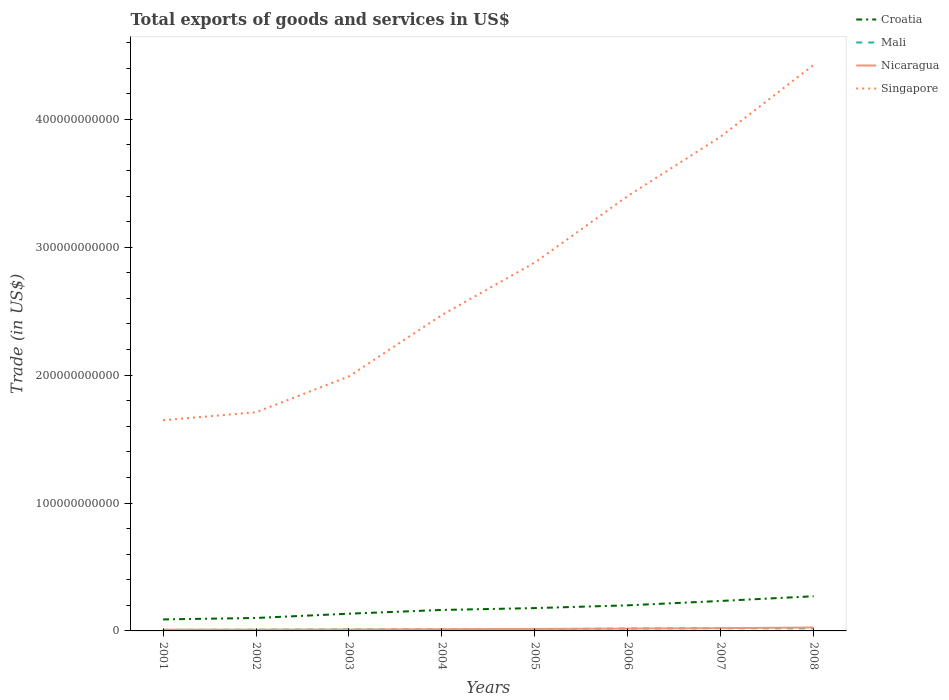Across all years, what is the maximum total exports of goods and services in Singapore?
Make the answer very short. 1.65e+11. In which year was the total exports of goods and services in Croatia maximum?
Offer a very short reply. 2001. What is the total total exports of goods and services in Mali in the graph?
Make the answer very short. -8.85e+08. What is the difference between the highest and the second highest total exports of goods and services in Nicaragua?
Offer a terse response. 1.68e+09. Is the total exports of goods and services in Singapore strictly greater than the total exports of goods and services in Nicaragua over the years?
Your answer should be very brief. No. How many years are there in the graph?
Offer a very short reply. 8. What is the difference between two consecutive major ticks on the Y-axis?
Ensure brevity in your answer.  1.00e+11. Does the graph contain any zero values?
Give a very brief answer. No. Where does the legend appear in the graph?
Provide a short and direct response. Top right. How are the legend labels stacked?
Ensure brevity in your answer.  Vertical. What is the title of the graph?
Your answer should be compact. Total exports of goods and services in US$. What is the label or title of the Y-axis?
Keep it short and to the point. Trade (in US$). What is the Trade (in US$) of Croatia in 2001?
Ensure brevity in your answer.  9.00e+09. What is the Trade (in US$) of Mali in 2001?
Your answer should be very brief. 7.89e+08. What is the Trade (in US$) of Nicaragua in 2001?
Offer a very short reply. 1.01e+09. What is the Trade (in US$) of Singapore in 2001?
Offer a terse response. 1.65e+11. What is the Trade (in US$) of Croatia in 2002?
Your response must be concise. 1.01e+1. What is the Trade (in US$) in Mali in 2002?
Make the answer very short. 9.47e+08. What is the Trade (in US$) in Nicaragua in 2002?
Your answer should be compact. 9.85e+08. What is the Trade (in US$) of Singapore in 2002?
Provide a succinct answer. 1.71e+11. What is the Trade (in US$) of Croatia in 2003?
Offer a terse response. 1.35e+1. What is the Trade (in US$) of Mali in 2003?
Provide a short and direct response. 1.15e+09. What is the Trade (in US$) in Nicaragua in 2003?
Keep it short and to the point. 1.10e+09. What is the Trade (in US$) of Singapore in 2003?
Offer a very short reply. 1.99e+11. What is the Trade (in US$) in Croatia in 2004?
Your answer should be compact. 1.64e+1. What is the Trade (in US$) of Mali in 2004?
Offer a very short reply. 1.22e+09. What is the Trade (in US$) in Nicaragua in 2004?
Your answer should be very brief. 1.34e+09. What is the Trade (in US$) in Singapore in 2004?
Your response must be concise. 2.47e+11. What is the Trade (in US$) in Croatia in 2005?
Your answer should be compact. 1.78e+1. What is the Trade (in US$) in Mali in 2005?
Keep it short and to the point. 1.37e+09. What is the Trade (in US$) of Nicaragua in 2005?
Provide a short and direct response. 1.54e+09. What is the Trade (in US$) in Singapore in 2005?
Offer a terse response. 2.88e+11. What is the Trade (in US$) in Croatia in 2006?
Provide a short and direct response. 2.00e+1. What is the Trade (in US$) in Mali in 2006?
Offer a terse response. 1.83e+09. What is the Trade (in US$) of Nicaragua in 2006?
Offer a very short reply. 1.83e+09. What is the Trade (in US$) of Singapore in 2006?
Provide a succinct answer. 3.40e+11. What is the Trade (in US$) of Croatia in 2007?
Offer a terse response. 2.34e+1. What is the Trade (in US$) in Mali in 2007?
Offer a terse response. 2.08e+09. What is the Trade (in US$) in Nicaragua in 2007?
Provide a short and direct response. 2.16e+09. What is the Trade (in US$) of Singapore in 2007?
Your response must be concise. 3.86e+11. What is the Trade (in US$) of Croatia in 2008?
Make the answer very short. 2.71e+1. What is the Trade (in US$) of Mali in 2008?
Give a very brief answer. 2.00e+09. What is the Trade (in US$) of Nicaragua in 2008?
Offer a terse response. 2.66e+09. What is the Trade (in US$) in Singapore in 2008?
Make the answer very short. 4.43e+11. Across all years, what is the maximum Trade (in US$) in Croatia?
Give a very brief answer. 2.71e+1. Across all years, what is the maximum Trade (in US$) in Mali?
Offer a terse response. 2.08e+09. Across all years, what is the maximum Trade (in US$) in Nicaragua?
Keep it short and to the point. 2.66e+09. Across all years, what is the maximum Trade (in US$) of Singapore?
Offer a very short reply. 4.43e+11. Across all years, what is the minimum Trade (in US$) of Croatia?
Your answer should be very brief. 9.00e+09. Across all years, what is the minimum Trade (in US$) of Mali?
Provide a short and direct response. 7.89e+08. Across all years, what is the minimum Trade (in US$) in Nicaragua?
Offer a very short reply. 9.85e+08. Across all years, what is the minimum Trade (in US$) of Singapore?
Make the answer very short. 1.65e+11. What is the total Trade (in US$) of Croatia in the graph?
Offer a very short reply. 1.37e+11. What is the total Trade (in US$) in Mali in the graph?
Provide a short and direct response. 1.14e+1. What is the total Trade (in US$) in Nicaragua in the graph?
Offer a very short reply. 1.26e+1. What is the total Trade (in US$) of Singapore in the graph?
Provide a succinct answer. 2.24e+12. What is the difference between the Trade (in US$) in Croatia in 2001 and that in 2002?
Provide a succinct answer. -1.12e+09. What is the difference between the Trade (in US$) in Mali in 2001 and that in 2002?
Your answer should be very brief. -1.58e+08. What is the difference between the Trade (in US$) of Nicaragua in 2001 and that in 2002?
Keep it short and to the point. 2.90e+07. What is the difference between the Trade (in US$) in Singapore in 2001 and that in 2002?
Offer a very short reply. -6.26e+09. What is the difference between the Trade (in US$) of Croatia in 2001 and that in 2003?
Offer a very short reply. -4.47e+09. What is the difference between the Trade (in US$) in Mali in 2001 and that in 2003?
Provide a short and direct response. -3.63e+08. What is the difference between the Trade (in US$) of Nicaragua in 2001 and that in 2003?
Provide a succinct answer. -8.84e+07. What is the difference between the Trade (in US$) of Singapore in 2001 and that in 2003?
Offer a very short reply. -3.43e+1. What is the difference between the Trade (in US$) of Croatia in 2001 and that in 2004?
Keep it short and to the point. -7.40e+09. What is the difference between the Trade (in US$) in Mali in 2001 and that in 2004?
Give a very brief answer. -4.28e+08. What is the difference between the Trade (in US$) of Nicaragua in 2001 and that in 2004?
Give a very brief answer. -3.23e+08. What is the difference between the Trade (in US$) of Singapore in 2001 and that in 2004?
Keep it short and to the point. -8.23e+1. What is the difference between the Trade (in US$) in Croatia in 2001 and that in 2005?
Offer a very short reply. -8.84e+09. What is the difference between the Trade (in US$) in Mali in 2001 and that in 2005?
Give a very brief answer. -5.84e+08. What is the difference between the Trade (in US$) of Nicaragua in 2001 and that in 2005?
Your answer should be very brief. -5.28e+08. What is the difference between the Trade (in US$) of Singapore in 2001 and that in 2005?
Make the answer very short. -1.23e+11. What is the difference between the Trade (in US$) in Croatia in 2001 and that in 2006?
Give a very brief answer. -1.10e+1. What is the difference between the Trade (in US$) in Mali in 2001 and that in 2006?
Offer a very short reply. -1.04e+09. What is the difference between the Trade (in US$) of Nicaragua in 2001 and that in 2006?
Your response must be concise. -8.21e+08. What is the difference between the Trade (in US$) of Singapore in 2001 and that in 2006?
Your response must be concise. -1.75e+11. What is the difference between the Trade (in US$) in Croatia in 2001 and that in 2007?
Give a very brief answer. -1.44e+1. What is the difference between the Trade (in US$) in Mali in 2001 and that in 2007?
Make the answer very short. -1.29e+09. What is the difference between the Trade (in US$) in Nicaragua in 2001 and that in 2007?
Ensure brevity in your answer.  -1.15e+09. What is the difference between the Trade (in US$) of Singapore in 2001 and that in 2007?
Make the answer very short. -2.22e+11. What is the difference between the Trade (in US$) of Croatia in 2001 and that in 2008?
Your answer should be compact. -1.81e+1. What is the difference between the Trade (in US$) in Mali in 2001 and that in 2008?
Give a very brief answer. -1.21e+09. What is the difference between the Trade (in US$) in Nicaragua in 2001 and that in 2008?
Make the answer very short. -1.65e+09. What is the difference between the Trade (in US$) in Singapore in 2001 and that in 2008?
Your answer should be compact. -2.78e+11. What is the difference between the Trade (in US$) of Croatia in 2002 and that in 2003?
Make the answer very short. -3.35e+09. What is the difference between the Trade (in US$) in Mali in 2002 and that in 2003?
Keep it short and to the point. -2.05e+08. What is the difference between the Trade (in US$) in Nicaragua in 2002 and that in 2003?
Provide a short and direct response. -1.17e+08. What is the difference between the Trade (in US$) in Singapore in 2002 and that in 2003?
Ensure brevity in your answer.  -2.80e+1. What is the difference between the Trade (in US$) of Croatia in 2002 and that in 2004?
Your response must be concise. -6.28e+09. What is the difference between the Trade (in US$) of Mali in 2002 and that in 2004?
Keep it short and to the point. -2.70e+08. What is the difference between the Trade (in US$) in Nicaragua in 2002 and that in 2004?
Offer a very short reply. -3.52e+08. What is the difference between the Trade (in US$) of Singapore in 2002 and that in 2004?
Your answer should be compact. -7.61e+1. What is the difference between the Trade (in US$) in Croatia in 2002 and that in 2005?
Offer a terse response. -7.72e+09. What is the difference between the Trade (in US$) in Mali in 2002 and that in 2005?
Ensure brevity in your answer.  -4.26e+08. What is the difference between the Trade (in US$) in Nicaragua in 2002 and that in 2005?
Your response must be concise. -5.57e+08. What is the difference between the Trade (in US$) in Singapore in 2002 and that in 2005?
Keep it short and to the point. -1.17e+11. What is the difference between the Trade (in US$) of Croatia in 2002 and that in 2006?
Give a very brief answer. -9.89e+09. What is the difference between the Trade (in US$) in Mali in 2002 and that in 2006?
Your answer should be very brief. -8.85e+08. What is the difference between the Trade (in US$) in Nicaragua in 2002 and that in 2006?
Provide a short and direct response. -8.50e+08. What is the difference between the Trade (in US$) in Singapore in 2002 and that in 2006?
Ensure brevity in your answer.  -1.69e+11. What is the difference between the Trade (in US$) in Croatia in 2002 and that in 2007?
Give a very brief answer. -1.33e+1. What is the difference between the Trade (in US$) in Mali in 2002 and that in 2007?
Your answer should be compact. -1.13e+09. What is the difference between the Trade (in US$) in Nicaragua in 2002 and that in 2007?
Ensure brevity in your answer.  -1.18e+09. What is the difference between the Trade (in US$) in Singapore in 2002 and that in 2007?
Your answer should be compact. -2.16e+11. What is the difference between the Trade (in US$) of Croatia in 2002 and that in 2008?
Provide a short and direct response. -1.70e+1. What is the difference between the Trade (in US$) of Mali in 2002 and that in 2008?
Offer a terse response. -1.05e+09. What is the difference between the Trade (in US$) of Nicaragua in 2002 and that in 2008?
Provide a succinct answer. -1.68e+09. What is the difference between the Trade (in US$) in Singapore in 2002 and that in 2008?
Your answer should be very brief. -2.72e+11. What is the difference between the Trade (in US$) of Croatia in 2003 and that in 2004?
Your response must be concise. -2.92e+09. What is the difference between the Trade (in US$) in Mali in 2003 and that in 2004?
Ensure brevity in your answer.  -6.55e+07. What is the difference between the Trade (in US$) of Nicaragua in 2003 and that in 2004?
Offer a very short reply. -2.34e+08. What is the difference between the Trade (in US$) of Singapore in 2003 and that in 2004?
Your answer should be very brief. -4.80e+1. What is the difference between the Trade (in US$) in Croatia in 2003 and that in 2005?
Make the answer very short. -4.37e+09. What is the difference between the Trade (in US$) of Mali in 2003 and that in 2005?
Your response must be concise. -2.21e+08. What is the difference between the Trade (in US$) in Nicaragua in 2003 and that in 2005?
Your response must be concise. -4.39e+08. What is the difference between the Trade (in US$) in Singapore in 2003 and that in 2005?
Offer a terse response. -8.91e+1. What is the difference between the Trade (in US$) of Croatia in 2003 and that in 2006?
Offer a very short reply. -6.53e+09. What is the difference between the Trade (in US$) of Mali in 2003 and that in 2006?
Provide a succinct answer. -6.80e+08. What is the difference between the Trade (in US$) in Nicaragua in 2003 and that in 2006?
Provide a short and direct response. -7.33e+08. What is the difference between the Trade (in US$) in Singapore in 2003 and that in 2006?
Make the answer very short. -1.41e+11. What is the difference between the Trade (in US$) of Croatia in 2003 and that in 2007?
Ensure brevity in your answer.  -9.96e+09. What is the difference between the Trade (in US$) of Mali in 2003 and that in 2007?
Keep it short and to the point. -9.26e+08. What is the difference between the Trade (in US$) of Nicaragua in 2003 and that in 2007?
Keep it short and to the point. -1.06e+09. What is the difference between the Trade (in US$) of Singapore in 2003 and that in 2007?
Offer a terse response. -1.87e+11. What is the difference between the Trade (in US$) in Croatia in 2003 and that in 2008?
Offer a terse response. -1.36e+1. What is the difference between the Trade (in US$) in Mali in 2003 and that in 2008?
Provide a succinct answer. -8.49e+08. What is the difference between the Trade (in US$) of Nicaragua in 2003 and that in 2008?
Offer a terse response. -1.56e+09. What is the difference between the Trade (in US$) of Singapore in 2003 and that in 2008?
Ensure brevity in your answer.  -2.44e+11. What is the difference between the Trade (in US$) of Croatia in 2004 and that in 2005?
Provide a succinct answer. -1.44e+09. What is the difference between the Trade (in US$) of Mali in 2004 and that in 2005?
Provide a short and direct response. -1.56e+08. What is the difference between the Trade (in US$) in Nicaragua in 2004 and that in 2005?
Offer a very short reply. -2.05e+08. What is the difference between the Trade (in US$) of Singapore in 2004 and that in 2005?
Make the answer very short. -4.10e+1. What is the difference between the Trade (in US$) in Croatia in 2004 and that in 2006?
Provide a succinct answer. -3.61e+09. What is the difference between the Trade (in US$) of Mali in 2004 and that in 2006?
Your response must be concise. -6.14e+08. What is the difference between the Trade (in US$) in Nicaragua in 2004 and that in 2006?
Make the answer very short. -4.98e+08. What is the difference between the Trade (in US$) in Singapore in 2004 and that in 2006?
Give a very brief answer. -9.31e+1. What is the difference between the Trade (in US$) of Croatia in 2004 and that in 2007?
Offer a terse response. -7.03e+09. What is the difference between the Trade (in US$) of Mali in 2004 and that in 2007?
Your answer should be compact. -8.60e+08. What is the difference between the Trade (in US$) of Nicaragua in 2004 and that in 2007?
Provide a short and direct response. -8.28e+08. What is the difference between the Trade (in US$) in Singapore in 2004 and that in 2007?
Ensure brevity in your answer.  -1.39e+11. What is the difference between the Trade (in US$) of Croatia in 2004 and that in 2008?
Your answer should be compact. -1.07e+1. What is the difference between the Trade (in US$) in Mali in 2004 and that in 2008?
Offer a terse response. -7.84e+08. What is the difference between the Trade (in US$) in Nicaragua in 2004 and that in 2008?
Provide a succinct answer. -1.32e+09. What is the difference between the Trade (in US$) in Singapore in 2004 and that in 2008?
Provide a succinct answer. -1.96e+11. What is the difference between the Trade (in US$) of Croatia in 2005 and that in 2006?
Give a very brief answer. -2.17e+09. What is the difference between the Trade (in US$) of Mali in 2005 and that in 2006?
Keep it short and to the point. -4.59e+08. What is the difference between the Trade (in US$) in Nicaragua in 2005 and that in 2006?
Your answer should be very brief. -2.94e+08. What is the difference between the Trade (in US$) of Singapore in 2005 and that in 2006?
Give a very brief answer. -5.20e+1. What is the difference between the Trade (in US$) of Croatia in 2005 and that in 2007?
Provide a short and direct response. -5.59e+09. What is the difference between the Trade (in US$) of Mali in 2005 and that in 2007?
Offer a terse response. -7.05e+08. What is the difference between the Trade (in US$) in Nicaragua in 2005 and that in 2007?
Ensure brevity in your answer.  -6.23e+08. What is the difference between the Trade (in US$) of Singapore in 2005 and that in 2007?
Your answer should be compact. -9.84e+1. What is the difference between the Trade (in US$) in Croatia in 2005 and that in 2008?
Offer a very short reply. -9.27e+09. What is the difference between the Trade (in US$) of Mali in 2005 and that in 2008?
Your answer should be very brief. -6.28e+08. What is the difference between the Trade (in US$) of Nicaragua in 2005 and that in 2008?
Your answer should be compact. -1.12e+09. What is the difference between the Trade (in US$) of Singapore in 2005 and that in 2008?
Ensure brevity in your answer.  -1.55e+11. What is the difference between the Trade (in US$) of Croatia in 2006 and that in 2007?
Provide a succinct answer. -3.43e+09. What is the difference between the Trade (in US$) of Mali in 2006 and that in 2007?
Your answer should be very brief. -2.46e+08. What is the difference between the Trade (in US$) in Nicaragua in 2006 and that in 2007?
Your answer should be compact. -3.29e+08. What is the difference between the Trade (in US$) of Singapore in 2006 and that in 2007?
Give a very brief answer. -4.64e+1. What is the difference between the Trade (in US$) in Croatia in 2006 and that in 2008?
Your response must be concise. -7.11e+09. What is the difference between the Trade (in US$) of Mali in 2006 and that in 2008?
Offer a very short reply. -1.69e+08. What is the difference between the Trade (in US$) of Nicaragua in 2006 and that in 2008?
Give a very brief answer. -8.25e+08. What is the difference between the Trade (in US$) in Singapore in 2006 and that in 2008?
Give a very brief answer. -1.03e+11. What is the difference between the Trade (in US$) in Croatia in 2007 and that in 2008?
Your response must be concise. -3.68e+09. What is the difference between the Trade (in US$) of Mali in 2007 and that in 2008?
Ensure brevity in your answer.  7.64e+07. What is the difference between the Trade (in US$) in Nicaragua in 2007 and that in 2008?
Keep it short and to the point. -4.96e+08. What is the difference between the Trade (in US$) of Singapore in 2007 and that in 2008?
Offer a very short reply. -5.61e+1. What is the difference between the Trade (in US$) of Croatia in 2001 and the Trade (in US$) of Mali in 2002?
Give a very brief answer. 8.06e+09. What is the difference between the Trade (in US$) of Croatia in 2001 and the Trade (in US$) of Nicaragua in 2002?
Keep it short and to the point. 8.02e+09. What is the difference between the Trade (in US$) in Croatia in 2001 and the Trade (in US$) in Singapore in 2002?
Provide a succinct answer. -1.62e+11. What is the difference between the Trade (in US$) of Mali in 2001 and the Trade (in US$) of Nicaragua in 2002?
Provide a short and direct response. -1.95e+08. What is the difference between the Trade (in US$) in Mali in 2001 and the Trade (in US$) in Singapore in 2002?
Keep it short and to the point. -1.70e+11. What is the difference between the Trade (in US$) in Nicaragua in 2001 and the Trade (in US$) in Singapore in 2002?
Make the answer very short. -1.70e+11. What is the difference between the Trade (in US$) of Croatia in 2001 and the Trade (in US$) of Mali in 2003?
Make the answer very short. 7.85e+09. What is the difference between the Trade (in US$) of Croatia in 2001 and the Trade (in US$) of Nicaragua in 2003?
Your answer should be compact. 7.90e+09. What is the difference between the Trade (in US$) of Croatia in 2001 and the Trade (in US$) of Singapore in 2003?
Your response must be concise. -1.90e+11. What is the difference between the Trade (in US$) of Mali in 2001 and the Trade (in US$) of Nicaragua in 2003?
Your answer should be compact. -3.13e+08. What is the difference between the Trade (in US$) in Mali in 2001 and the Trade (in US$) in Singapore in 2003?
Make the answer very short. -1.98e+11. What is the difference between the Trade (in US$) in Nicaragua in 2001 and the Trade (in US$) in Singapore in 2003?
Make the answer very short. -1.98e+11. What is the difference between the Trade (in US$) of Croatia in 2001 and the Trade (in US$) of Mali in 2004?
Keep it short and to the point. 7.79e+09. What is the difference between the Trade (in US$) of Croatia in 2001 and the Trade (in US$) of Nicaragua in 2004?
Give a very brief answer. 7.67e+09. What is the difference between the Trade (in US$) in Croatia in 2001 and the Trade (in US$) in Singapore in 2004?
Provide a short and direct response. -2.38e+11. What is the difference between the Trade (in US$) of Mali in 2001 and the Trade (in US$) of Nicaragua in 2004?
Ensure brevity in your answer.  -5.47e+08. What is the difference between the Trade (in US$) in Mali in 2001 and the Trade (in US$) in Singapore in 2004?
Ensure brevity in your answer.  -2.46e+11. What is the difference between the Trade (in US$) in Nicaragua in 2001 and the Trade (in US$) in Singapore in 2004?
Make the answer very short. -2.46e+11. What is the difference between the Trade (in US$) in Croatia in 2001 and the Trade (in US$) in Mali in 2005?
Offer a very short reply. 7.63e+09. What is the difference between the Trade (in US$) of Croatia in 2001 and the Trade (in US$) of Nicaragua in 2005?
Your answer should be very brief. 7.46e+09. What is the difference between the Trade (in US$) of Croatia in 2001 and the Trade (in US$) of Singapore in 2005?
Make the answer very short. -2.79e+11. What is the difference between the Trade (in US$) of Mali in 2001 and the Trade (in US$) of Nicaragua in 2005?
Make the answer very short. -7.52e+08. What is the difference between the Trade (in US$) in Mali in 2001 and the Trade (in US$) in Singapore in 2005?
Ensure brevity in your answer.  -2.87e+11. What is the difference between the Trade (in US$) of Nicaragua in 2001 and the Trade (in US$) of Singapore in 2005?
Your answer should be compact. -2.87e+11. What is the difference between the Trade (in US$) in Croatia in 2001 and the Trade (in US$) in Mali in 2006?
Make the answer very short. 7.17e+09. What is the difference between the Trade (in US$) in Croatia in 2001 and the Trade (in US$) in Nicaragua in 2006?
Your answer should be very brief. 7.17e+09. What is the difference between the Trade (in US$) of Croatia in 2001 and the Trade (in US$) of Singapore in 2006?
Offer a very short reply. -3.31e+11. What is the difference between the Trade (in US$) of Mali in 2001 and the Trade (in US$) of Nicaragua in 2006?
Provide a succinct answer. -1.05e+09. What is the difference between the Trade (in US$) of Mali in 2001 and the Trade (in US$) of Singapore in 2006?
Give a very brief answer. -3.39e+11. What is the difference between the Trade (in US$) in Nicaragua in 2001 and the Trade (in US$) in Singapore in 2006?
Provide a succinct answer. -3.39e+11. What is the difference between the Trade (in US$) of Croatia in 2001 and the Trade (in US$) of Mali in 2007?
Provide a succinct answer. 6.93e+09. What is the difference between the Trade (in US$) in Croatia in 2001 and the Trade (in US$) in Nicaragua in 2007?
Offer a terse response. 6.84e+09. What is the difference between the Trade (in US$) of Croatia in 2001 and the Trade (in US$) of Singapore in 2007?
Provide a short and direct response. -3.77e+11. What is the difference between the Trade (in US$) in Mali in 2001 and the Trade (in US$) in Nicaragua in 2007?
Provide a short and direct response. -1.38e+09. What is the difference between the Trade (in US$) of Mali in 2001 and the Trade (in US$) of Singapore in 2007?
Offer a terse response. -3.86e+11. What is the difference between the Trade (in US$) of Nicaragua in 2001 and the Trade (in US$) of Singapore in 2007?
Your answer should be very brief. -3.85e+11. What is the difference between the Trade (in US$) in Croatia in 2001 and the Trade (in US$) in Mali in 2008?
Provide a succinct answer. 7.00e+09. What is the difference between the Trade (in US$) in Croatia in 2001 and the Trade (in US$) in Nicaragua in 2008?
Make the answer very short. 6.34e+09. What is the difference between the Trade (in US$) in Croatia in 2001 and the Trade (in US$) in Singapore in 2008?
Ensure brevity in your answer.  -4.34e+11. What is the difference between the Trade (in US$) in Mali in 2001 and the Trade (in US$) in Nicaragua in 2008?
Offer a terse response. -1.87e+09. What is the difference between the Trade (in US$) of Mali in 2001 and the Trade (in US$) of Singapore in 2008?
Ensure brevity in your answer.  -4.42e+11. What is the difference between the Trade (in US$) in Nicaragua in 2001 and the Trade (in US$) in Singapore in 2008?
Keep it short and to the point. -4.42e+11. What is the difference between the Trade (in US$) in Croatia in 2002 and the Trade (in US$) in Mali in 2003?
Offer a terse response. 8.97e+09. What is the difference between the Trade (in US$) in Croatia in 2002 and the Trade (in US$) in Nicaragua in 2003?
Give a very brief answer. 9.02e+09. What is the difference between the Trade (in US$) of Croatia in 2002 and the Trade (in US$) of Singapore in 2003?
Provide a short and direct response. -1.89e+11. What is the difference between the Trade (in US$) of Mali in 2002 and the Trade (in US$) of Nicaragua in 2003?
Provide a short and direct response. -1.55e+08. What is the difference between the Trade (in US$) in Mali in 2002 and the Trade (in US$) in Singapore in 2003?
Give a very brief answer. -1.98e+11. What is the difference between the Trade (in US$) in Nicaragua in 2002 and the Trade (in US$) in Singapore in 2003?
Keep it short and to the point. -1.98e+11. What is the difference between the Trade (in US$) in Croatia in 2002 and the Trade (in US$) in Mali in 2004?
Offer a very short reply. 8.91e+09. What is the difference between the Trade (in US$) in Croatia in 2002 and the Trade (in US$) in Nicaragua in 2004?
Give a very brief answer. 8.79e+09. What is the difference between the Trade (in US$) in Croatia in 2002 and the Trade (in US$) in Singapore in 2004?
Give a very brief answer. -2.37e+11. What is the difference between the Trade (in US$) of Mali in 2002 and the Trade (in US$) of Nicaragua in 2004?
Give a very brief answer. -3.89e+08. What is the difference between the Trade (in US$) in Mali in 2002 and the Trade (in US$) in Singapore in 2004?
Your answer should be very brief. -2.46e+11. What is the difference between the Trade (in US$) of Nicaragua in 2002 and the Trade (in US$) of Singapore in 2004?
Offer a terse response. -2.46e+11. What is the difference between the Trade (in US$) of Croatia in 2002 and the Trade (in US$) of Mali in 2005?
Keep it short and to the point. 8.75e+09. What is the difference between the Trade (in US$) in Croatia in 2002 and the Trade (in US$) in Nicaragua in 2005?
Keep it short and to the point. 8.58e+09. What is the difference between the Trade (in US$) of Croatia in 2002 and the Trade (in US$) of Singapore in 2005?
Offer a very short reply. -2.78e+11. What is the difference between the Trade (in US$) in Mali in 2002 and the Trade (in US$) in Nicaragua in 2005?
Keep it short and to the point. -5.94e+08. What is the difference between the Trade (in US$) in Mali in 2002 and the Trade (in US$) in Singapore in 2005?
Your answer should be compact. -2.87e+11. What is the difference between the Trade (in US$) in Nicaragua in 2002 and the Trade (in US$) in Singapore in 2005?
Offer a very short reply. -2.87e+11. What is the difference between the Trade (in US$) of Croatia in 2002 and the Trade (in US$) of Mali in 2006?
Give a very brief answer. 8.29e+09. What is the difference between the Trade (in US$) in Croatia in 2002 and the Trade (in US$) in Nicaragua in 2006?
Give a very brief answer. 8.29e+09. What is the difference between the Trade (in US$) of Croatia in 2002 and the Trade (in US$) of Singapore in 2006?
Keep it short and to the point. -3.30e+11. What is the difference between the Trade (in US$) in Mali in 2002 and the Trade (in US$) in Nicaragua in 2006?
Your answer should be very brief. -8.88e+08. What is the difference between the Trade (in US$) in Mali in 2002 and the Trade (in US$) in Singapore in 2006?
Make the answer very short. -3.39e+11. What is the difference between the Trade (in US$) of Nicaragua in 2002 and the Trade (in US$) of Singapore in 2006?
Provide a succinct answer. -3.39e+11. What is the difference between the Trade (in US$) in Croatia in 2002 and the Trade (in US$) in Mali in 2007?
Give a very brief answer. 8.05e+09. What is the difference between the Trade (in US$) of Croatia in 2002 and the Trade (in US$) of Nicaragua in 2007?
Give a very brief answer. 7.96e+09. What is the difference between the Trade (in US$) of Croatia in 2002 and the Trade (in US$) of Singapore in 2007?
Ensure brevity in your answer.  -3.76e+11. What is the difference between the Trade (in US$) in Mali in 2002 and the Trade (in US$) in Nicaragua in 2007?
Your response must be concise. -1.22e+09. What is the difference between the Trade (in US$) in Mali in 2002 and the Trade (in US$) in Singapore in 2007?
Keep it short and to the point. -3.86e+11. What is the difference between the Trade (in US$) of Nicaragua in 2002 and the Trade (in US$) of Singapore in 2007?
Offer a terse response. -3.86e+11. What is the difference between the Trade (in US$) of Croatia in 2002 and the Trade (in US$) of Mali in 2008?
Keep it short and to the point. 8.12e+09. What is the difference between the Trade (in US$) in Croatia in 2002 and the Trade (in US$) in Nicaragua in 2008?
Your response must be concise. 7.47e+09. What is the difference between the Trade (in US$) in Croatia in 2002 and the Trade (in US$) in Singapore in 2008?
Make the answer very short. -4.33e+11. What is the difference between the Trade (in US$) in Mali in 2002 and the Trade (in US$) in Nicaragua in 2008?
Ensure brevity in your answer.  -1.71e+09. What is the difference between the Trade (in US$) in Mali in 2002 and the Trade (in US$) in Singapore in 2008?
Offer a terse response. -4.42e+11. What is the difference between the Trade (in US$) in Nicaragua in 2002 and the Trade (in US$) in Singapore in 2008?
Provide a succinct answer. -4.42e+11. What is the difference between the Trade (in US$) in Croatia in 2003 and the Trade (in US$) in Mali in 2004?
Offer a very short reply. 1.23e+1. What is the difference between the Trade (in US$) in Croatia in 2003 and the Trade (in US$) in Nicaragua in 2004?
Give a very brief answer. 1.21e+1. What is the difference between the Trade (in US$) in Croatia in 2003 and the Trade (in US$) in Singapore in 2004?
Keep it short and to the point. -2.34e+11. What is the difference between the Trade (in US$) of Mali in 2003 and the Trade (in US$) of Nicaragua in 2004?
Keep it short and to the point. -1.84e+08. What is the difference between the Trade (in US$) in Mali in 2003 and the Trade (in US$) in Singapore in 2004?
Ensure brevity in your answer.  -2.46e+11. What is the difference between the Trade (in US$) in Nicaragua in 2003 and the Trade (in US$) in Singapore in 2004?
Ensure brevity in your answer.  -2.46e+11. What is the difference between the Trade (in US$) of Croatia in 2003 and the Trade (in US$) of Mali in 2005?
Your response must be concise. 1.21e+1. What is the difference between the Trade (in US$) in Croatia in 2003 and the Trade (in US$) in Nicaragua in 2005?
Offer a terse response. 1.19e+1. What is the difference between the Trade (in US$) in Croatia in 2003 and the Trade (in US$) in Singapore in 2005?
Your answer should be compact. -2.75e+11. What is the difference between the Trade (in US$) in Mali in 2003 and the Trade (in US$) in Nicaragua in 2005?
Give a very brief answer. -3.89e+08. What is the difference between the Trade (in US$) in Mali in 2003 and the Trade (in US$) in Singapore in 2005?
Offer a very short reply. -2.87e+11. What is the difference between the Trade (in US$) in Nicaragua in 2003 and the Trade (in US$) in Singapore in 2005?
Make the answer very short. -2.87e+11. What is the difference between the Trade (in US$) of Croatia in 2003 and the Trade (in US$) of Mali in 2006?
Your answer should be very brief. 1.16e+1. What is the difference between the Trade (in US$) in Croatia in 2003 and the Trade (in US$) in Nicaragua in 2006?
Offer a terse response. 1.16e+1. What is the difference between the Trade (in US$) in Croatia in 2003 and the Trade (in US$) in Singapore in 2006?
Make the answer very short. -3.27e+11. What is the difference between the Trade (in US$) of Mali in 2003 and the Trade (in US$) of Nicaragua in 2006?
Your answer should be compact. -6.83e+08. What is the difference between the Trade (in US$) in Mali in 2003 and the Trade (in US$) in Singapore in 2006?
Offer a terse response. -3.39e+11. What is the difference between the Trade (in US$) in Nicaragua in 2003 and the Trade (in US$) in Singapore in 2006?
Provide a succinct answer. -3.39e+11. What is the difference between the Trade (in US$) of Croatia in 2003 and the Trade (in US$) of Mali in 2007?
Make the answer very short. 1.14e+1. What is the difference between the Trade (in US$) in Croatia in 2003 and the Trade (in US$) in Nicaragua in 2007?
Offer a terse response. 1.13e+1. What is the difference between the Trade (in US$) of Croatia in 2003 and the Trade (in US$) of Singapore in 2007?
Your answer should be compact. -3.73e+11. What is the difference between the Trade (in US$) in Mali in 2003 and the Trade (in US$) in Nicaragua in 2007?
Give a very brief answer. -1.01e+09. What is the difference between the Trade (in US$) of Mali in 2003 and the Trade (in US$) of Singapore in 2007?
Provide a succinct answer. -3.85e+11. What is the difference between the Trade (in US$) of Nicaragua in 2003 and the Trade (in US$) of Singapore in 2007?
Provide a short and direct response. -3.85e+11. What is the difference between the Trade (in US$) of Croatia in 2003 and the Trade (in US$) of Mali in 2008?
Provide a short and direct response. 1.15e+1. What is the difference between the Trade (in US$) in Croatia in 2003 and the Trade (in US$) in Nicaragua in 2008?
Ensure brevity in your answer.  1.08e+1. What is the difference between the Trade (in US$) of Croatia in 2003 and the Trade (in US$) of Singapore in 2008?
Make the answer very short. -4.29e+11. What is the difference between the Trade (in US$) of Mali in 2003 and the Trade (in US$) of Nicaragua in 2008?
Your response must be concise. -1.51e+09. What is the difference between the Trade (in US$) of Mali in 2003 and the Trade (in US$) of Singapore in 2008?
Make the answer very short. -4.41e+11. What is the difference between the Trade (in US$) of Nicaragua in 2003 and the Trade (in US$) of Singapore in 2008?
Your answer should be compact. -4.42e+11. What is the difference between the Trade (in US$) of Croatia in 2004 and the Trade (in US$) of Mali in 2005?
Give a very brief answer. 1.50e+1. What is the difference between the Trade (in US$) of Croatia in 2004 and the Trade (in US$) of Nicaragua in 2005?
Make the answer very short. 1.49e+1. What is the difference between the Trade (in US$) in Croatia in 2004 and the Trade (in US$) in Singapore in 2005?
Provide a short and direct response. -2.72e+11. What is the difference between the Trade (in US$) in Mali in 2004 and the Trade (in US$) in Nicaragua in 2005?
Keep it short and to the point. -3.24e+08. What is the difference between the Trade (in US$) of Mali in 2004 and the Trade (in US$) of Singapore in 2005?
Your answer should be compact. -2.87e+11. What is the difference between the Trade (in US$) in Nicaragua in 2004 and the Trade (in US$) in Singapore in 2005?
Provide a succinct answer. -2.87e+11. What is the difference between the Trade (in US$) of Croatia in 2004 and the Trade (in US$) of Mali in 2006?
Offer a very short reply. 1.46e+1. What is the difference between the Trade (in US$) of Croatia in 2004 and the Trade (in US$) of Nicaragua in 2006?
Give a very brief answer. 1.46e+1. What is the difference between the Trade (in US$) of Croatia in 2004 and the Trade (in US$) of Singapore in 2006?
Your answer should be compact. -3.24e+11. What is the difference between the Trade (in US$) in Mali in 2004 and the Trade (in US$) in Nicaragua in 2006?
Offer a terse response. -6.17e+08. What is the difference between the Trade (in US$) in Mali in 2004 and the Trade (in US$) in Singapore in 2006?
Keep it short and to the point. -3.39e+11. What is the difference between the Trade (in US$) of Nicaragua in 2004 and the Trade (in US$) of Singapore in 2006?
Offer a terse response. -3.39e+11. What is the difference between the Trade (in US$) in Croatia in 2004 and the Trade (in US$) in Mali in 2007?
Keep it short and to the point. 1.43e+1. What is the difference between the Trade (in US$) of Croatia in 2004 and the Trade (in US$) of Nicaragua in 2007?
Your response must be concise. 1.42e+1. What is the difference between the Trade (in US$) in Croatia in 2004 and the Trade (in US$) in Singapore in 2007?
Your response must be concise. -3.70e+11. What is the difference between the Trade (in US$) of Mali in 2004 and the Trade (in US$) of Nicaragua in 2007?
Give a very brief answer. -9.47e+08. What is the difference between the Trade (in US$) in Mali in 2004 and the Trade (in US$) in Singapore in 2007?
Your response must be concise. -3.85e+11. What is the difference between the Trade (in US$) in Nicaragua in 2004 and the Trade (in US$) in Singapore in 2007?
Your answer should be compact. -3.85e+11. What is the difference between the Trade (in US$) in Croatia in 2004 and the Trade (in US$) in Mali in 2008?
Your answer should be compact. 1.44e+1. What is the difference between the Trade (in US$) in Croatia in 2004 and the Trade (in US$) in Nicaragua in 2008?
Provide a short and direct response. 1.37e+1. What is the difference between the Trade (in US$) in Croatia in 2004 and the Trade (in US$) in Singapore in 2008?
Your answer should be compact. -4.26e+11. What is the difference between the Trade (in US$) of Mali in 2004 and the Trade (in US$) of Nicaragua in 2008?
Your response must be concise. -1.44e+09. What is the difference between the Trade (in US$) of Mali in 2004 and the Trade (in US$) of Singapore in 2008?
Your response must be concise. -4.41e+11. What is the difference between the Trade (in US$) in Nicaragua in 2004 and the Trade (in US$) in Singapore in 2008?
Provide a short and direct response. -4.41e+11. What is the difference between the Trade (in US$) of Croatia in 2005 and the Trade (in US$) of Mali in 2006?
Offer a very short reply. 1.60e+1. What is the difference between the Trade (in US$) of Croatia in 2005 and the Trade (in US$) of Nicaragua in 2006?
Offer a terse response. 1.60e+1. What is the difference between the Trade (in US$) in Croatia in 2005 and the Trade (in US$) in Singapore in 2006?
Keep it short and to the point. -3.22e+11. What is the difference between the Trade (in US$) of Mali in 2005 and the Trade (in US$) of Nicaragua in 2006?
Ensure brevity in your answer.  -4.62e+08. What is the difference between the Trade (in US$) of Mali in 2005 and the Trade (in US$) of Singapore in 2006?
Keep it short and to the point. -3.39e+11. What is the difference between the Trade (in US$) in Nicaragua in 2005 and the Trade (in US$) in Singapore in 2006?
Your answer should be very brief. -3.39e+11. What is the difference between the Trade (in US$) of Croatia in 2005 and the Trade (in US$) of Mali in 2007?
Give a very brief answer. 1.58e+1. What is the difference between the Trade (in US$) of Croatia in 2005 and the Trade (in US$) of Nicaragua in 2007?
Make the answer very short. 1.57e+1. What is the difference between the Trade (in US$) of Croatia in 2005 and the Trade (in US$) of Singapore in 2007?
Make the answer very short. -3.69e+11. What is the difference between the Trade (in US$) in Mali in 2005 and the Trade (in US$) in Nicaragua in 2007?
Give a very brief answer. -7.91e+08. What is the difference between the Trade (in US$) of Mali in 2005 and the Trade (in US$) of Singapore in 2007?
Provide a short and direct response. -3.85e+11. What is the difference between the Trade (in US$) in Nicaragua in 2005 and the Trade (in US$) in Singapore in 2007?
Your answer should be compact. -3.85e+11. What is the difference between the Trade (in US$) of Croatia in 2005 and the Trade (in US$) of Mali in 2008?
Provide a succinct answer. 1.58e+1. What is the difference between the Trade (in US$) in Croatia in 2005 and the Trade (in US$) in Nicaragua in 2008?
Your answer should be compact. 1.52e+1. What is the difference between the Trade (in US$) in Croatia in 2005 and the Trade (in US$) in Singapore in 2008?
Keep it short and to the point. -4.25e+11. What is the difference between the Trade (in US$) of Mali in 2005 and the Trade (in US$) of Nicaragua in 2008?
Your response must be concise. -1.29e+09. What is the difference between the Trade (in US$) in Mali in 2005 and the Trade (in US$) in Singapore in 2008?
Offer a terse response. -4.41e+11. What is the difference between the Trade (in US$) in Nicaragua in 2005 and the Trade (in US$) in Singapore in 2008?
Keep it short and to the point. -4.41e+11. What is the difference between the Trade (in US$) in Croatia in 2006 and the Trade (in US$) in Mali in 2007?
Make the answer very short. 1.79e+1. What is the difference between the Trade (in US$) in Croatia in 2006 and the Trade (in US$) in Nicaragua in 2007?
Keep it short and to the point. 1.78e+1. What is the difference between the Trade (in US$) in Croatia in 2006 and the Trade (in US$) in Singapore in 2007?
Offer a very short reply. -3.66e+11. What is the difference between the Trade (in US$) in Mali in 2006 and the Trade (in US$) in Nicaragua in 2007?
Keep it short and to the point. -3.32e+08. What is the difference between the Trade (in US$) in Mali in 2006 and the Trade (in US$) in Singapore in 2007?
Your response must be concise. -3.85e+11. What is the difference between the Trade (in US$) in Nicaragua in 2006 and the Trade (in US$) in Singapore in 2007?
Provide a short and direct response. -3.85e+11. What is the difference between the Trade (in US$) of Croatia in 2006 and the Trade (in US$) of Mali in 2008?
Give a very brief answer. 1.80e+1. What is the difference between the Trade (in US$) of Croatia in 2006 and the Trade (in US$) of Nicaragua in 2008?
Make the answer very short. 1.74e+1. What is the difference between the Trade (in US$) of Croatia in 2006 and the Trade (in US$) of Singapore in 2008?
Offer a very short reply. -4.23e+11. What is the difference between the Trade (in US$) in Mali in 2006 and the Trade (in US$) in Nicaragua in 2008?
Make the answer very short. -8.28e+08. What is the difference between the Trade (in US$) of Mali in 2006 and the Trade (in US$) of Singapore in 2008?
Make the answer very short. -4.41e+11. What is the difference between the Trade (in US$) of Nicaragua in 2006 and the Trade (in US$) of Singapore in 2008?
Your response must be concise. -4.41e+11. What is the difference between the Trade (in US$) of Croatia in 2007 and the Trade (in US$) of Mali in 2008?
Give a very brief answer. 2.14e+1. What is the difference between the Trade (in US$) in Croatia in 2007 and the Trade (in US$) in Nicaragua in 2008?
Ensure brevity in your answer.  2.08e+1. What is the difference between the Trade (in US$) of Croatia in 2007 and the Trade (in US$) of Singapore in 2008?
Keep it short and to the point. -4.19e+11. What is the difference between the Trade (in US$) of Mali in 2007 and the Trade (in US$) of Nicaragua in 2008?
Make the answer very short. -5.82e+08. What is the difference between the Trade (in US$) of Mali in 2007 and the Trade (in US$) of Singapore in 2008?
Provide a short and direct response. -4.41e+11. What is the difference between the Trade (in US$) in Nicaragua in 2007 and the Trade (in US$) in Singapore in 2008?
Give a very brief answer. -4.40e+11. What is the average Trade (in US$) of Croatia per year?
Offer a terse response. 1.72e+1. What is the average Trade (in US$) of Mali per year?
Offer a terse response. 1.42e+09. What is the average Trade (in US$) in Nicaragua per year?
Give a very brief answer. 1.58e+09. What is the average Trade (in US$) of Singapore per year?
Your answer should be compact. 2.80e+11. In the year 2001, what is the difference between the Trade (in US$) of Croatia and Trade (in US$) of Mali?
Your response must be concise. 8.22e+09. In the year 2001, what is the difference between the Trade (in US$) in Croatia and Trade (in US$) in Nicaragua?
Your answer should be compact. 7.99e+09. In the year 2001, what is the difference between the Trade (in US$) of Croatia and Trade (in US$) of Singapore?
Your response must be concise. -1.56e+11. In the year 2001, what is the difference between the Trade (in US$) of Mali and Trade (in US$) of Nicaragua?
Ensure brevity in your answer.  -2.24e+08. In the year 2001, what is the difference between the Trade (in US$) of Mali and Trade (in US$) of Singapore?
Make the answer very short. -1.64e+11. In the year 2001, what is the difference between the Trade (in US$) of Nicaragua and Trade (in US$) of Singapore?
Your answer should be compact. -1.64e+11. In the year 2002, what is the difference between the Trade (in US$) in Croatia and Trade (in US$) in Mali?
Your response must be concise. 9.18e+09. In the year 2002, what is the difference between the Trade (in US$) of Croatia and Trade (in US$) of Nicaragua?
Your answer should be very brief. 9.14e+09. In the year 2002, what is the difference between the Trade (in US$) of Croatia and Trade (in US$) of Singapore?
Offer a terse response. -1.61e+11. In the year 2002, what is the difference between the Trade (in US$) in Mali and Trade (in US$) in Nicaragua?
Your answer should be very brief. -3.73e+07. In the year 2002, what is the difference between the Trade (in US$) of Mali and Trade (in US$) of Singapore?
Provide a succinct answer. -1.70e+11. In the year 2002, what is the difference between the Trade (in US$) of Nicaragua and Trade (in US$) of Singapore?
Offer a very short reply. -1.70e+11. In the year 2003, what is the difference between the Trade (in US$) of Croatia and Trade (in US$) of Mali?
Your response must be concise. 1.23e+1. In the year 2003, what is the difference between the Trade (in US$) in Croatia and Trade (in US$) in Nicaragua?
Your answer should be compact. 1.24e+1. In the year 2003, what is the difference between the Trade (in US$) of Croatia and Trade (in US$) of Singapore?
Offer a very short reply. -1.86e+11. In the year 2003, what is the difference between the Trade (in US$) of Mali and Trade (in US$) of Nicaragua?
Offer a very short reply. 5.01e+07. In the year 2003, what is the difference between the Trade (in US$) in Mali and Trade (in US$) in Singapore?
Provide a succinct answer. -1.98e+11. In the year 2003, what is the difference between the Trade (in US$) of Nicaragua and Trade (in US$) of Singapore?
Give a very brief answer. -1.98e+11. In the year 2004, what is the difference between the Trade (in US$) in Croatia and Trade (in US$) in Mali?
Provide a short and direct response. 1.52e+1. In the year 2004, what is the difference between the Trade (in US$) in Croatia and Trade (in US$) in Nicaragua?
Provide a short and direct response. 1.51e+1. In the year 2004, what is the difference between the Trade (in US$) of Croatia and Trade (in US$) of Singapore?
Your answer should be very brief. -2.31e+11. In the year 2004, what is the difference between the Trade (in US$) of Mali and Trade (in US$) of Nicaragua?
Your answer should be very brief. -1.19e+08. In the year 2004, what is the difference between the Trade (in US$) of Mali and Trade (in US$) of Singapore?
Your answer should be very brief. -2.46e+11. In the year 2004, what is the difference between the Trade (in US$) of Nicaragua and Trade (in US$) of Singapore?
Provide a succinct answer. -2.46e+11. In the year 2005, what is the difference between the Trade (in US$) in Croatia and Trade (in US$) in Mali?
Your answer should be very brief. 1.65e+1. In the year 2005, what is the difference between the Trade (in US$) in Croatia and Trade (in US$) in Nicaragua?
Give a very brief answer. 1.63e+1. In the year 2005, what is the difference between the Trade (in US$) in Croatia and Trade (in US$) in Singapore?
Offer a terse response. -2.70e+11. In the year 2005, what is the difference between the Trade (in US$) in Mali and Trade (in US$) in Nicaragua?
Ensure brevity in your answer.  -1.68e+08. In the year 2005, what is the difference between the Trade (in US$) of Mali and Trade (in US$) of Singapore?
Make the answer very short. -2.87e+11. In the year 2005, what is the difference between the Trade (in US$) of Nicaragua and Trade (in US$) of Singapore?
Your response must be concise. -2.87e+11. In the year 2006, what is the difference between the Trade (in US$) of Croatia and Trade (in US$) of Mali?
Offer a very short reply. 1.82e+1. In the year 2006, what is the difference between the Trade (in US$) in Croatia and Trade (in US$) in Nicaragua?
Provide a succinct answer. 1.82e+1. In the year 2006, what is the difference between the Trade (in US$) in Croatia and Trade (in US$) in Singapore?
Provide a short and direct response. -3.20e+11. In the year 2006, what is the difference between the Trade (in US$) of Mali and Trade (in US$) of Nicaragua?
Your answer should be compact. -2.89e+06. In the year 2006, what is the difference between the Trade (in US$) in Mali and Trade (in US$) in Singapore?
Your answer should be very brief. -3.38e+11. In the year 2006, what is the difference between the Trade (in US$) in Nicaragua and Trade (in US$) in Singapore?
Offer a very short reply. -3.38e+11. In the year 2007, what is the difference between the Trade (in US$) in Croatia and Trade (in US$) in Mali?
Your response must be concise. 2.14e+1. In the year 2007, what is the difference between the Trade (in US$) in Croatia and Trade (in US$) in Nicaragua?
Your answer should be compact. 2.13e+1. In the year 2007, what is the difference between the Trade (in US$) of Croatia and Trade (in US$) of Singapore?
Keep it short and to the point. -3.63e+11. In the year 2007, what is the difference between the Trade (in US$) in Mali and Trade (in US$) in Nicaragua?
Give a very brief answer. -8.64e+07. In the year 2007, what is the difference between the Trade (in US$) of Mali and Trade (in US$) of Singapore?
Offer a very short reply. -3.84e+11. In the year 2007, what is the difference between the Trade (in US$) in Nicaragua and Trade (in US$) in Singapore?
Make the answer very short. -3.84e+11. In the year 2008, what is the difference between the Trade (in US$) in Croatia and Trade (in US$) in Mali?
Provide a short and direct response. 2.51e+1. In the year 2008, what is the difference between the Trade (in US$) in Croatia and Trade (in US$) in Nicaragua?
Offer a terse response. 2.45e+1. In the year 2008, what is the difference between the Trade (in US$) of Croatia and Trade (in US$) of Singapore?
Offer a very short reply. -4.16e+11. In the year 2008, what is the difference between the Trade (in US$) in Mali and Trade (in US$) in Nicaragua?
Provide a short and direct response. -6.59e+08. In the year 2008, what is the difference between the Trade (in US$) of Mali and Trade (in US$) of Singapore?
Your answer should be very brief. -4.41e+11. In the year 2008, what is the difference between the Trade (in US$) in Nicaragua and Trade (in US$) in Singapore?
Offer a very short reply. -4.40e+11. What is the ratio of the Trade (in US$) of Croatia in 2001 to that in 2002?
Provide a short and direct response. 0.89. What is the ratio of the Trade (in US$) in Mali in 2001 to that in 2002?
Provide a short and direct response. 0.83. What is the ratio of the Trade (in US$) of Nicaragua in 2001 to that in 2002?
Your answer should be compact. 1.03. What is the ratio of the Trade (in US$) in Singapore in 2001 to that in 2002?
Your answer should be very brief. 0.96. What is the ratio of the Trade (in US$) in Croatia in 2001 to that in 2003?
Give a very brief answer. 0.67. What is the ratio of the Trade (in US$) in Mali in 2001 to that in 2003?
Provide a succinct answer. 0.69. What is the ratio of the Trade (in US$) of Nicaragua in 2001 to that in 2003?
Provide a short and direct response. 0.92. What is the ratio of the Trade (in US$) of Singapore in 2001 to that in 2003?
Your answer should be very brief. 0.83. What is the ratio of the Trade (in US$) of Croatia in 2001 to that in 2004?
Ensure brevity in your answer.  0.55. What is the ratio of the Trade (in US$) in Mali in 2001 to that in 2004?
Offer a terse response. 0.65. What is the ratio of the Trade (in US$) in Nicaragua in 2001 to that in 2004?
Your answer should be very brief. 0.76. What is the ratio of the Trade (in US$) of Singapore in 2001 to that in 2004?
Provide a short and direct response. 0.67. What is the ratio of the Trade (in US$) in Croatia in 2001 to that in 2005?
Make the answer very short. 0.5. What is the ratio of the Trade (in US$) in Mali in 2001 to that in 2005?
Provide a succinct answer. 0.57. What is the ratio of the Trade (in US$) of Nicaragua in 2001 to that in 2005?
Your answer should be compact. 0.66. What is the ratio of the Trade (in US$) in Singapore in 2001 to that in 2005?
Provide a short and direct response. 0.57. What is the ratio of the Trade (in US$) in Croatia in 2001 to that in 2006?
Your answer should be very brief. 0.45. What is the ratio of the Trade (in US$) in Mali in 2001 to that in 2006?
Ensure brevity in your answer.  0.43. What is the ratio of the Trade (in US$) of Nicaragua in 2001 to that in 2006?
Keep it short and to the point. 0.55. What is the ratio of the Trade (in US$) in Singapore in 2001 to that in 2006?
Offer a terse response. 0.48. What is the ratio of the Trade (in US$) of Croatia in 2001 to that in 2007?
Your answer should be compact. 0.38. What is the ratio of the Trade (in US$) in Mali in 2001 to that in 2007?
Give a very brief answer. 0.38. What is the ratio of the Trade (in US$) of Nicaragua in 2001 to that in 2007?
Offer a terse response. 0.47. What is the ratio of the Trade (in US$) of Singapore in 2001 to that in 2007?
Your response must be concise. 0.43. What is the ratio of the Trade (in US$) in Croatia in 2001 to that in 2008?
Provide a short and direct response. 0.33. What is the ratio of the Trade (in US$) in Mali in 2001 to that in 2008?
Your answer should be compact. 0.39. What is the ratio of the Trade (in US$) of Nicaragua in 2001 to that in 2008?
Provide a succinct answer. 0.38. What is the ratio of the Trade (in US$) in Singapore in 2001 to that in 2008?
Your answer should be very brief. 0.37. What is the ratio of the Trade (in US$) in Croatia in 2002 to that in 2003?
Ensure brevity in your answer.  0.75. What is the ratio of the Trade (in US$) in Mali in 2002 to that in 2003?
Provide a short and direct response. 0.82. What is the ratio of the Trade (in US$) of Nicaragua in 2002 to that in 2003?
Provide a succinct answer. 0.89. What is the ratio of the Trade (in US$) in Singapore in 2002 to that in 2003?
Give a very brief answer. 0.86. What is the ratio of the Trade (in US$) in Croatia in 2002 to that in 2004?
Make the answer very short. 0.62. What is the ratio of the Trade (in US$) of Mali in 2002 to that in 2004?
Keep it short and to the point. 0.78. What is the ratio of the Trade (in US$) in Nicaragua in 2002 to that in 2004?
Ensure brevity in your answer.  0.74. What is the ratio of the Trade (in US$) in Singapore in 2002 to that in 2004?
Your answer should be compact. 0.69. What is the ratio of the Trade (in US$) of Croatia in 2002 to that in 2005?
Offer a terse response. 0.57. What is the ratio of the Trade (in US$) in Mali in 2002 to that in 2005?
Provide a short and direct response. 0.69. What is the ratio of the Trade (in US$) of Nicaragua in 2002 to that in 2005?
Provide a succinct answer. 0.64. What is the ratio of the Trade (in US$) of Singapore in 2002 to that in 2005?
Give a very brief answer. 0.59. What is the ratio of the Trade (in US$) in Croatia in 2002 to that in 2006?
Offer a very short reply. 0.51. What is the ratio of the Trade (in US$) of Mali in 2002 to that in 2006?
Offer a terse response. 0.52. What is the ratio of the Trade (in US$) of Nicaragua in 2002 to that in 2006?
Offer a very short reply. 0.54. What is the ratio of the Trade (in US$) in Singapore in 2002 to that in 2006?
Keep it short and to the point. 0.5. What is the ratio of the Trade (in US$) in Croatia in 2002 to that in 2007?
Offer a terse response. 0.43. What is the ratio of the Trade (in US$) in Mali in 2002 to that in 2007?
Give a very brief answer. 0.46. What is the ratio of the Trade (in US$) of Nicaragua in 2002 to that in 2007?
Make the answer very short. 0.45. What is the ratio of the Trade (in US$) of Singapore in 2002 to that in 2007?
Your answer should be compact. 0.44. What is the ratio of the Trade (in US$) of Croatia in 2002 to that in 2008?
Provide a short and direct response. 0.37. What is the ratio of the Trade (in US$) of Mali in 2002 to that in 2008?
Offer a terse response. 0.47. What is the ratio of the Trade (in US$) in Nicaragua in 2002 to that in 2008?
Offer a very short reply. 0.37. What is the ratio of the Trade (in US$) in Singapore in 2002 to that in 2008?
Make the answer very short. 0.39. What is the ratio of the Trade (in US$) in Croatia in 2003 to that in 2004?
Provide a succinct answer. 0.82. What is the ratio of the Trade (in US$) in Mali in 2003 to that in 2004?
Ensure brevity in your answer.  0.95. What is the ratio of the Trade (in US$) in Nicaragua in 2003 to that in 2004?
Your answer should be very brief. 0.82. What is the ratio of the Trade (in US$) in Singapore in 2003 to that in 2004?
Make the answer very short. 0.81. What is the ratio of the Trade (in US$) in Croatia in 2003 to that in 2005?
Make the answer very short. 0.76. What is the ratio of the Trade (in US$) of Mali in 2003 to that in 2005?
Provide a short and direct response. 0.84. What is the ratio of the Trade (in US$) in Nicaragua in 2003 to that in 2005?
Keep it short and to the point. 0.71. What is the ratio of the Trade (in US$) of Singapore in 2003 to that in 2005?
Ensure brevity in your answer.  0.69. What is the ratio of the Trade (in US$) in Croatia in 2003 to that in 2006?
Make the answer very short. 0.67. What is the ratio of the Trade (in US$) in Mali in 2003 to that in 2006?
Keep it short and to the point. 0.63. What is the ratio of the Trade (in US$) of Nicaragua in 2003 to that in 2006?
Offer a very short reply. 0.6. What is the ratio of the Trade (in US$) of Singapore in 2003 to that in 2006?
Your answer should be very brief. 0.59. What is the ratio of the Trade (in US$) of Croatia in 2003 to that in 2007?
Your answer should be very brief. 0.58. What is the ratio of the Trade (in US$) in Mali in 2003 to that in 2007?
Your answer should be compact. 0.55. What is the ratio of the Trade (in US$) of Nicaragua in 2003 to that in 2007?
Provide a short and direct response. 0.51. What is the ratio of the Trade (in US$) in Singapore in 2003 to that in 2007?
Give a very brief answer. 0.51. What is the ratio of the Trade (in US$) of Croatia in 2003 to that in 2008?
Offer a terse response. 0.5. What is the ratio of the Trade (in US$) in Mali in 2003 to that in 2008?
Ensure brevity in your answer.  0.58. What is the ratio of the Trade (in US$) of Nicaragua in 2003 to that in 2008?
Your response must be concise. 0.41. What is the ratio of the Trade (in US$) in Singapore in 2003 to that in 2008?
Provide a succinct answer. 0.45. What is the ratio of the Trade (in US$) in Croatia in 2004 to that in 2005?
Make the answer very short. 0.92. What is the ratio of the Trade (in US$) in Mali in 2004 to that in 2005?
Your answer should be compact. 0.89. What is the ratio of the Trade (in US$) of Nicaragua in 2004 to that in 2005?
Provide a short and direct response. 0.87. What is the ratio of the Trade (in US$) of Singapore in 2004 to that in 2005?
Offer a terse response. 0.86. What is the ratio of the Trade (in US$) in Croatia in 2004 to that in 2006?
Provide a succinct answer. 0.82. What is the ratio of the Trade (in US$) in Mali in 2004 to that in 2006?
Provide a short and direct response. 0.66. What is the ratio of the Trade (in US$) of Nicaragua in 2004 to that in 2006?
Your answer should be very brief. 0.73. What is the ratio of the Trade (in US$) of Singapore in 2004 to that in 2006?
Give a very brief answer. 0.73. What is the ratio of the Trade (in US$) of Croatia in 2004 to that in 2007?
Keep it short and to the point. 0.7. What is the ratio of the Trade (in US$) of Mali in 2004 to that in 2007?
Provide a short and direct response. 0.59. What is the ratio of the Trade (in US$) in Nicaragua in 2004 to that in 2007?
Provide a succinct answer. 0.62. What is the ratio of the Trade (in US$) of Singapore in 2004 to that in 2007?
Provide a succinct answer. 0.64. What is the ratio of the Trade (in US$) in Croatia in 2004 to that in 2008?
Provide a succinct answer. 0.6. What is the ratio of the Trade (in US$) in Mali in 2004 to that in 2008?
Provide a short and direct response. 0.61. What is the ratio of the Trade (in US$) of Nicaragua in 2004 to that in 2008?
Your answer should be compact. 0.5. What is the ratio of the Trade (in US$) in Singapore in 2004 to that in 2008?
Offer a very short reply. 0.56. What is the ratio of the Trade (in US$) in Croatia in 2005 to that in 2006?
Make the answer very short. 0.89. What is the ratio of the Trade (in US$) in Mali in 2005 to that in 2006?
Your answer should be very brief. 0.75. What is the ratio of the Trade (in US$) in Nicaragua in 2005 to that in 2006?
Keep it short and to the point. 0.84. What is the ratio of the Trade (in US$) in Singapore in 2005 to that in 2006?
Your response must be concise. 0.85. What is the ratio of the Trade (in US$) of Croatia in 2005 to that in 2007?
Your answer should be compact. 0.76. What is the ratio of the Trade (in US$) in Mali in 2005 to that in 2007?
Offer a terse response. 0.66. What is the ratio of the Trade (in US$) of Nicaragua in 2005 to that in 2007?
Your answer should be very brief. 0.71. What is the ratio of the Trade (in US$) of Singapore in 2005 to that in 2007?
Offer a very short reply. 0.75. What is the ratio of the Trade (in US$) in Croatia in 2005 to that in 2008?
Offer a very short reply. 0.66. What is the ratio of the Trade (in US$) of Mali in 2005 to that in 2008?
Your response must be concise. 0.69. What is the ratio of the Trade (in US$) of Nicaragua in 2005 to that in 2008?
Make the answer very short. 0.58. What is the ratio of the Trade (in US$) of Singapore in 2005 to that in 2008?
Your response must be concise. 0.65. What is the ratio of the Trade (in US$) in Croatia in 2006 to that in 2007?
Your answer should be compact. 0.85. What is the ratio of the Trade (in US$) of Mali in 2006 to that in 2007?
Offer a very short reply. 0.88. What is the ratio of the Trade (in US$) of Nicaragua in 2006 to that in 2007?
Offer a very short reply. 0.85. What is the ratio of the Trade (in US$) in Singapore in 2006 to that in 2007?
Offer a very short reply. 0.88. What is the ratio of the Trade (in US$) in Croatia in 2006 to that in 2008?
Give a very brief answer. 0.74. What is the ratio of the Trade (in US$) of Mali in 2006 to that in 2008?
Make the answer very short. 0.92. What is the ratio of the Trade (in US$) of Nicaragua in 2006 to that in 2008?
Your response must be concise. 0.69. What is the ratio of the Trade (in US$) of Singapore in 2006 to that in 2008?
Your answer should be very brief. 0.77. What is the ratio of the Trade (in US$) in Croatia in 2007 to that in 2008?
Give a very brief answer. 0.86. What is the ratio of the Trade (in US$) of Mali in 2007 to that in 2008?
Make the answer very short. 1.04. What is the ratio of the Trade (in US$) of Nicaragua in 2007 to that in 2008?
Your response must be concise. 0.81. What is the ratio of the Trade (in US$) in Singapore in 2007 to that in 2008?
Keep it short and to the point. 0.87. What is the difference between the highest and the second highest Trade (in US$) in Croatia?
Give a very brief answer. 3.68e+09. What is the difference between the highest and the second highest Trade (in US$) of Mali?
Provide a short and direct response. 7.64e+07. What is the difference between the highest and the second highest Trade (in US$) in Nicaragua?
Your answer should be compact. 4.96e+08. What is the difference between the highest and the second highest Trade (in US$) in Singapore?
Ensure brevity in your answer.  5.61e+1. What is the difference between the highest and the lowest Trade (in US$) of Croatia?
Keep it short and to the point. 1.81e+1. What is the difference between the highest and the lowest Trade (in US$) in Mali?
Your response must be concise. 1.29e+09. What is the difference between the highest and the lowest Trade (in US$) in Nicaragua?
Offer a terse response. 1.68e+09. What is the difference between the highest and the lowest Trade (in US$) of Singapore?
Provide a short and direct response. 2.78e+11. 